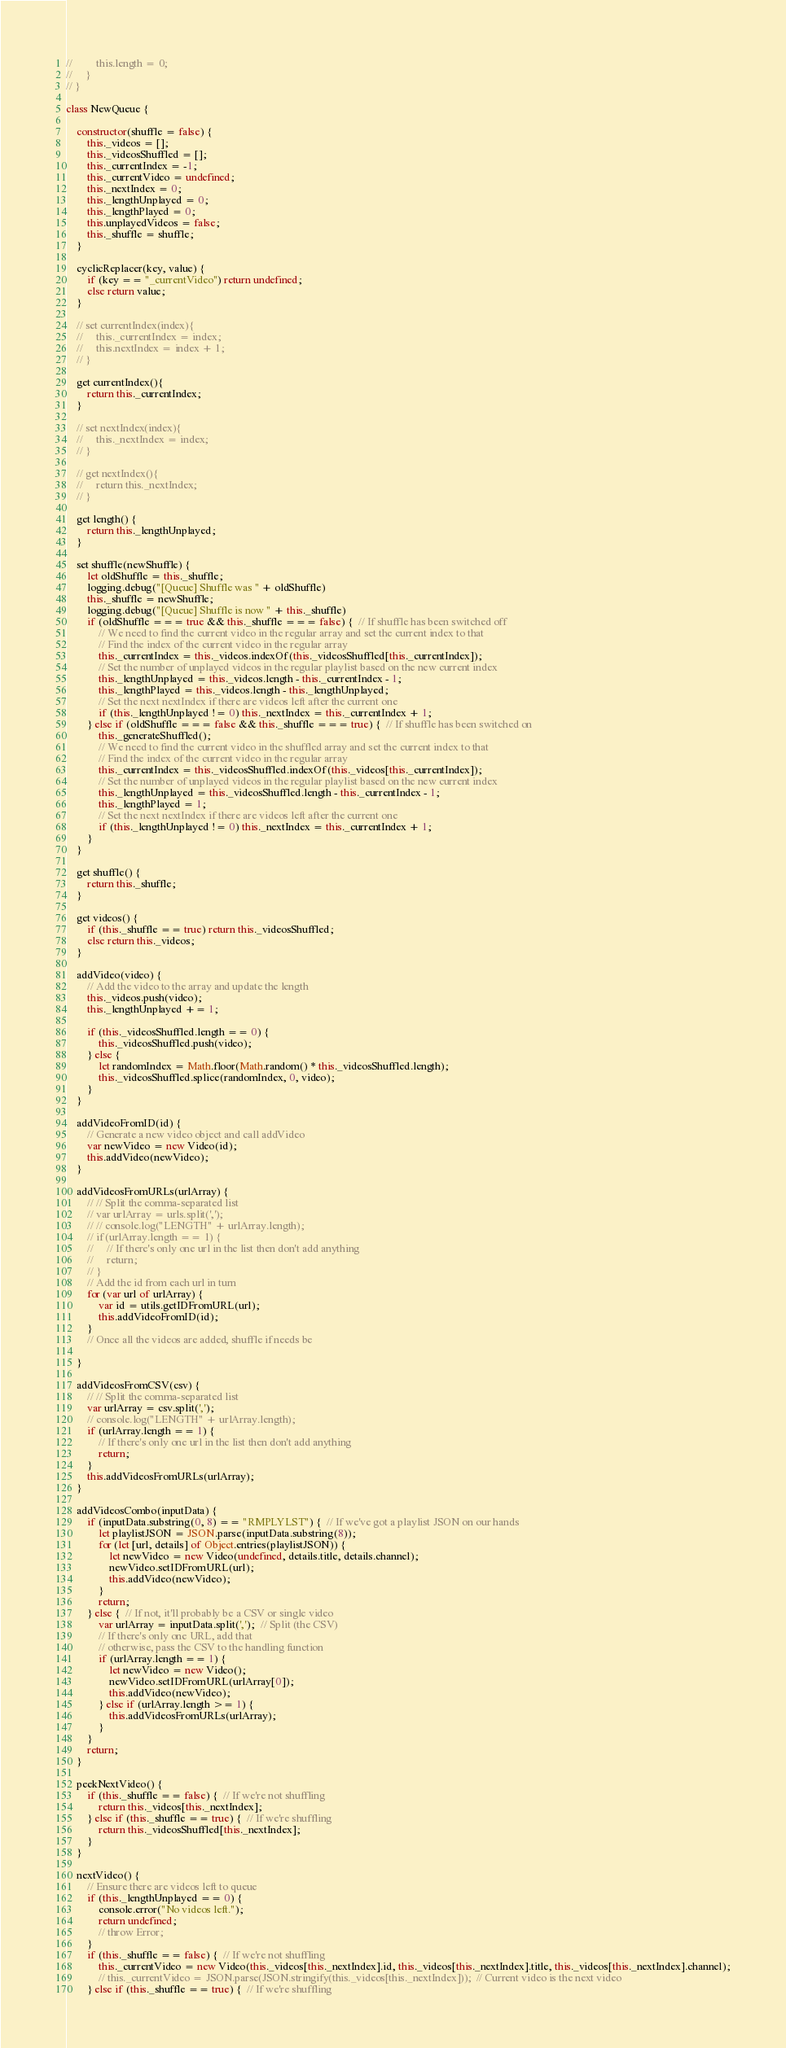<code> <loc_0><loc_0><loc_500><loc_500><_JavaScript_>//         this.length = 0;
//     }
// }

class NewQueue {

    constructor(shuffle = false) {
        this._videos = [];
        this._videosShuffled = [];
        this._currentIndex = -1;
        this._currentVideo = undefined;
        this._nextIndex = 0;
        this._lengthUnplayed = 0;
        this._lengthPlayed = 0;
        this.unplayedVideos = false;
        this._shuffle = shuffle;
    }

    cyclicReplacer(key, value) {
        if (key == "_currentVideo") return undefined;
        else return value;
    }

    // set currentIndex(index){
    //     this._currentIndex = index;
    //     this.nextIndex = index + 1;
    // }

    get currentIndex(){
        return this._currentIndex;
    }

    // set nextIndex(index){
    //     this._nextIndex = index;
    // }

    // get nextIndex(){
    //     return this._nextIndex;
    // }

    get length() {
        return this._lengthUnplayed;
    }

    set shuffle(newShuffle) {
        let oldShuffle = this._shuffle;
        logging.debug("[Queue] Shuffle was " + oldShuffle)
        this._shuffle = newShuffle;
        logging.debug("[Queue] Shuffle is now " + this._shuffle)
        if (oldShuffle === true && this._shuffle === false) {  // If shuffle has been switched off
            // We need to find the current video in the regular array and set the current index to that
            // Find the index of the current video in the regular array
            this._currentIndex = this._videos.indexOf(this._videosShuffled[this._currentIndex]);
            // Set the number of unplayed videos in the regular playlist based on the new current index
            this._lengthUnplayed = this._videos.length - this._currentIndex - 1;
            this._lengthPlayed = this._videos.length - this._lengthUnplayed;
            // Set the next nextIndex if there are videos left after the current one
            if (this._lengthUnplayed != 0) this._nextIndex = this._currentIndex + 1;
        } else if (oldShuffle === false && this._shuffle === true) {  // If shuffle has been switched on
            this._generateShuffled();
            // We need to find the current video in the shuffled array and set the current index to that
            // Find the index of the current video in the regular array
            this._currentIndex = this._videosShuffled.indexOf(this._videos[this._currentIndex]);
            // Set the number of unplayed videos in the regular playlist based on the new current index
            this._lengthUnplayed = this._videosShuffled.length - this._currentIndex - 1;
            this._lengthPlayed = 1;
            // Set the next nextIndex if there are videos left after the current one
            if (this._lengthUnplayed != 0) this._nextIndex = this._currentIndex + 1;
        }
    }

    get shuffle() {
        return this._shuffle;
    }

    get videos() {
        if (this._shuffle == true) return this._videosShuffled;
        else return this._videos;
    }

    addVideo(video) {
        // Add the video to the array and update the length
        this._videos.push(video);
        this._lengthUnplayed += 1;

        if (this._videosShuffled.length == 0) {
            this._videosShuffled.push(video);
        } else {
            let randomIndex = Math.floor(Math.random() * this._videosShuffled.length);
            this._videosShuffled.splice(randomIndex, 0, video);
        }
    }

    addVideoFromID(id) {
        // Generate a new video object and call addVideo
        var newVideo = new Video(id);
        this.addVideo(newVideo);
    }

    addVideosFromURLs(urlArray) {
        // // Split the comma-separated list
        // var urlArray = urls.split(',');
        // // console.log("LENGTH" + urlArray.length);
        // if (urlArray.length == 1) {
        //     // If there's only one url in the list then don't add anything
        //     return;
        // }
        // Add the id from each url in turn
        for (var url of urlArray) {
            var id = utils.getIDFromURL(url);
            this.addVideoFromID(id);
        }
        // Once all the videos are added, shuffle if needs be

    }

    addVideosFromCSV(csv) {
        // // Split the comma-separated list
        var urlArray = csv.split(',');
        // console.log("LENGTH" + urlArray.length);
        if (urlArray.length == 1) {
            // If there's only one url in the list then don't add anything
            return;
        }
        this.addVideosFromURLs(urlArray);
    }

    addVideosCombo(inputData) {
        if (inputData.substring(0, 8) == "RMPLYLST") {  // If we've got a playlist JSON on our hands
            let playlistJSON = JSON.parse(inputData.substring(8));
            for (let [url, details] of Object.entries(playlistJSON)) {
                let newVideo = new Video(undefined, details.title, details.channel);
                newVideo.setIDFromURL(url);
                this.addVideo(newVideo);
            }
            return;
        } else {  // If not, it'll probably be a CSV or single video
            var urlArray = inputData.split(',');  // Split (the CSV)
            // If there's only one URL, add that
            // otherwise, pass the CSV to the handling function
            if (urlArray.length == 1) {
                let newVideo = new Video();
                newVideo.setIDFromURL(urlArray[0]);
                this.addVideo(newVideo);
            } else if (urlArray.length >= 1) {
                this.addVideosFromURLs(urlArray);
            }
        }
        return;
    }

    peekNextVideo() {
        if (this._shuffle == false) {  // If we're not shuffling
            return this._videos[this._nextIndex];
        } else if (this._shuffle == true) {  // If we're shuffling
            return this._videosShuffled[this._nextIndex];
        }
    }

    nextVideo() {
        // Ensure there are videos left to queue
        if (this._lengthUnplayed == 0) {
            console.error("No videos left.");
            return undefined;
            // throw Error;
        }
        if (this._shuffle == false) {  // If we're not shuffling
            this._currentVideo = new Video(this._videos[this._nextIndex].id, this._videos[this._nextIndex].title, this._videos[this._nextIndex].channel);
            // this._currentVideo = JSON.parse(JSON.stringify(this._videos[this._nextIndex]));  // Current video is the next video
        } else if (this._shuffle == true) {  // If we're shuffling</code> 